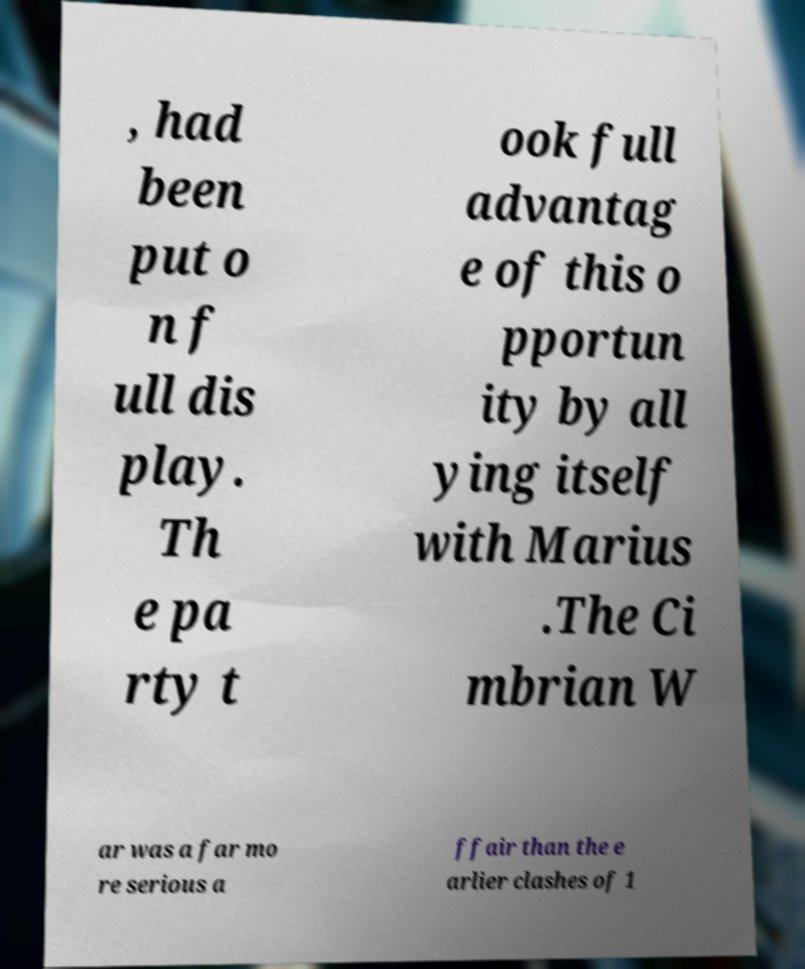Can you read and provide the text displayed in the image?This photo seems to have some interesting text. Can you extract and type it out for me? , had been put o n f ull dis play. Th e pa rty t ook full advantag e of this o pportun ity by all ying itself with Marius .The Ci mbrian W ar was a far mo re serious a ffair than the e arlier clashes of 1 